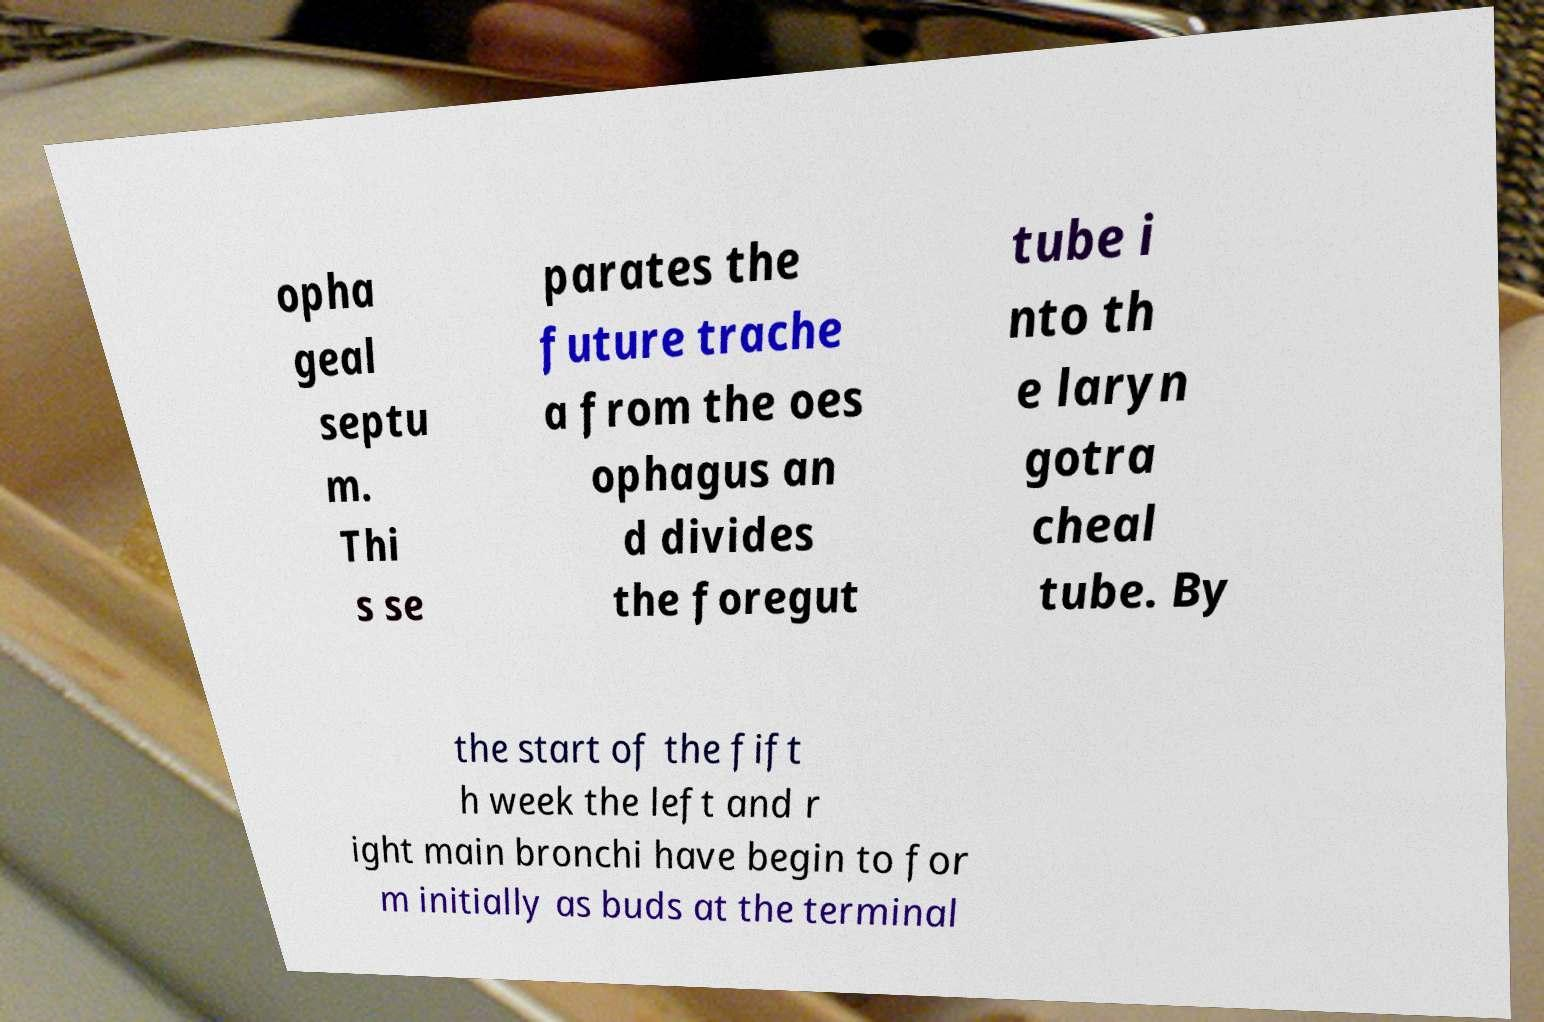What messages or text are displayed in this image? I need them in a readable, typed format. opha geal septu m. Thi s se parates the future trache a from the oes ophagus an d divides the foregut tube i nto th e laryn gotra cheal tube. By the start of the fift h week the left and r ight main bronchi have begin to for m initially as buds at the terminal 